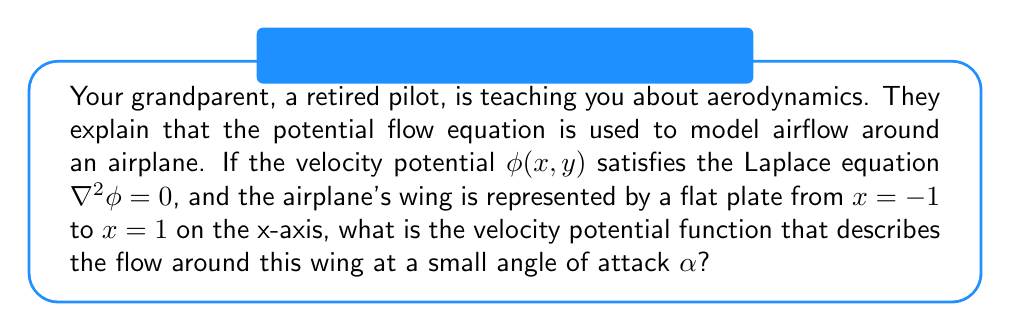Teach me how to tackle this problem. To solve this problem, we'll follow these steps:

1) The Laplace equation in 2D is:

   $$\frac{\partial^2\phi}{\partial x^2} + \frac{\partial^2\phi}{\partial y^2} = 0$$

2) For a flat plate at a small angle of attack, we can use the thin airfoil theory. The velocity potential can be approximated as a superposition of uniform flow and circulation:

   $$\phi(x,y) = U_\infty(x\cos\alpha + y\sin\alpha) + \frac{\Gamma}{2\pi}\tan^{-1}\left(\frac{y}{x}\right)$$

   Where $U_\infty$ is the freestream velocity and $\Gamma$ is the circulation.

3) The circulation $\Gamma$ is related to the angle of attack by the Kutta condition:

   $$\Gamma = 2\pi U_\infty \alpha$$

4) Substituting this into our velocity potential:

   $$\phi(x,y) = U_\infty(x\cos\alpha + y\sin\alpha) + U_\infty\alpha\tan^{-1}\left(\frac{y}{x}\right)$$

5) For small angles, we can approximate $\cos\alpha \approx 1$ and $\sin\alpha \approx \alpha$:

   $$\phi(x,y) = U_\infty\left(x + \alpha y + \alpha\tan^{-1}\left(\frac{y}{x}\right)\right)$$

This is the velocity potential function that describes the flow around the wing at a small angle of attack.
Answer: $$\phi(x,y) = U_\infty\left(x + \alpha y + \alpha\tan^{-1}\left(\frac{y}{x}\right)\right)$$ 